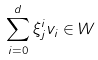Convert formula to latex. <formula><loc_0><loc_0><loc_500><loc_500>\sum ^ { d } _ { i = 0 } \xi _ { j } ^ { i } v _ { i } \in W</formula> 